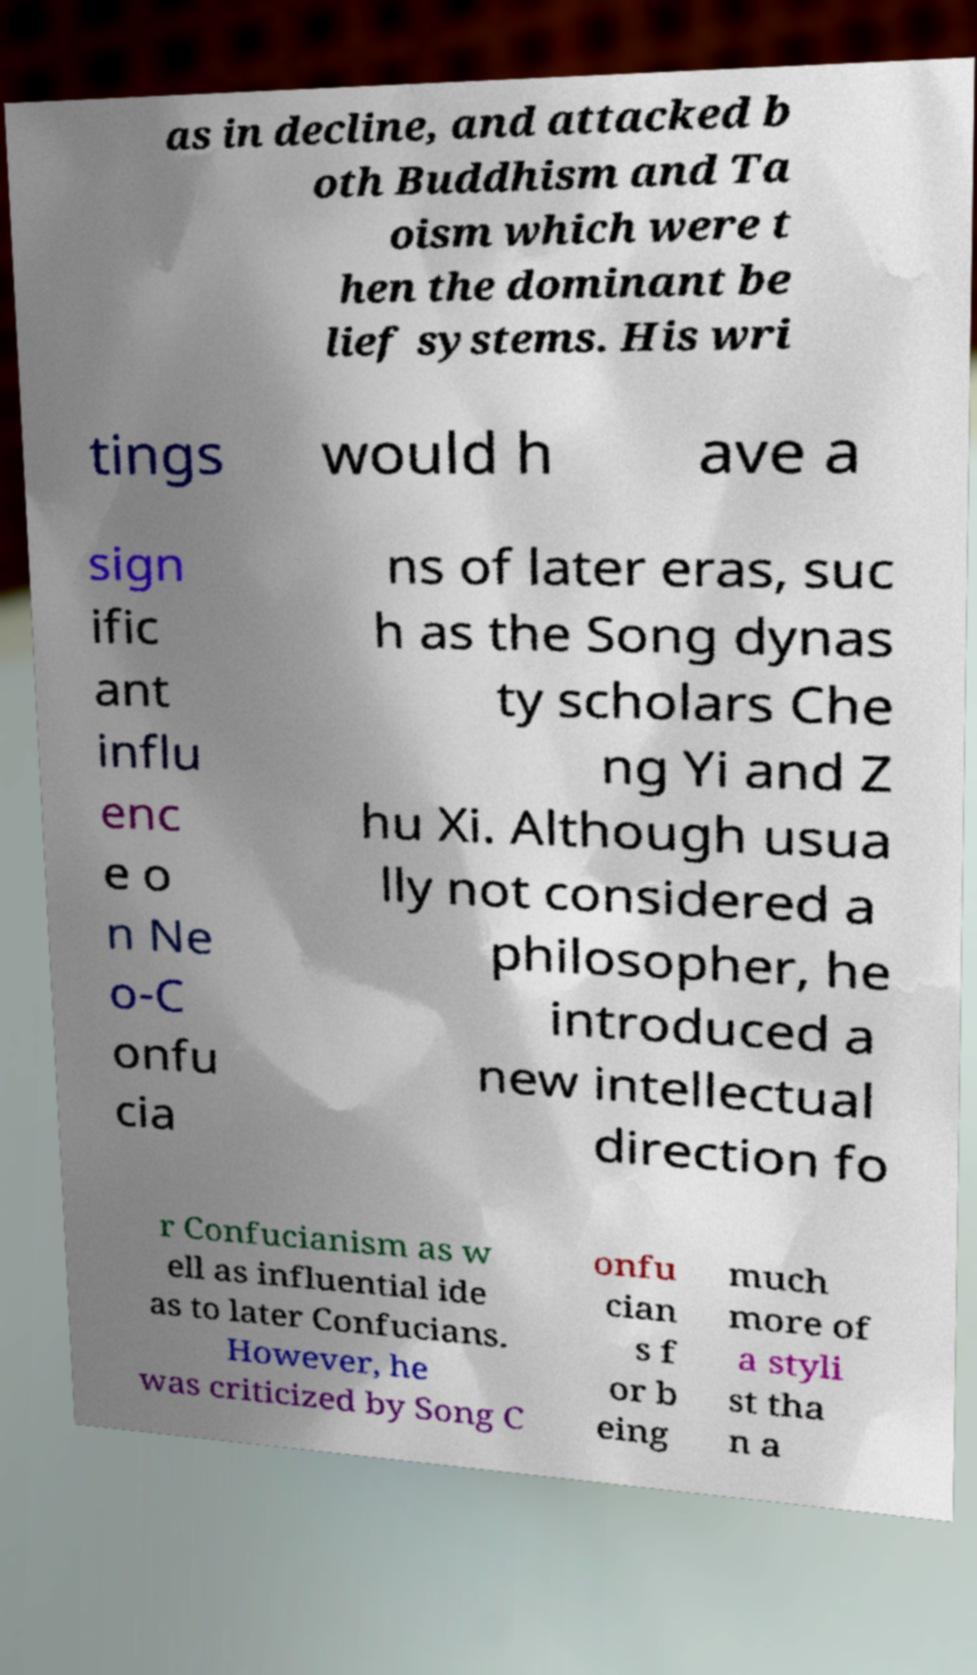There's text embedded in this image that I need extracted. Can you transcribe it verbatim? as in decline, and attacked b oth Buddhism and Ta oism which were t hen the dominant be lief systems. His wri tings would h ave a sign ific ant influ enc e o n Ne o-C onfu cia ns of later eras, suc h as the Song dynas ty scholars Che ng Yi and Z hu Xi. Although usua lly not considered a philosopher, he introduced a new intellectual direction fo r Confucianism as w ell as influential ide as to later Confucians. However, he was criticized by Song C onfu cian s f or b eing much more of a styli st tha n a 